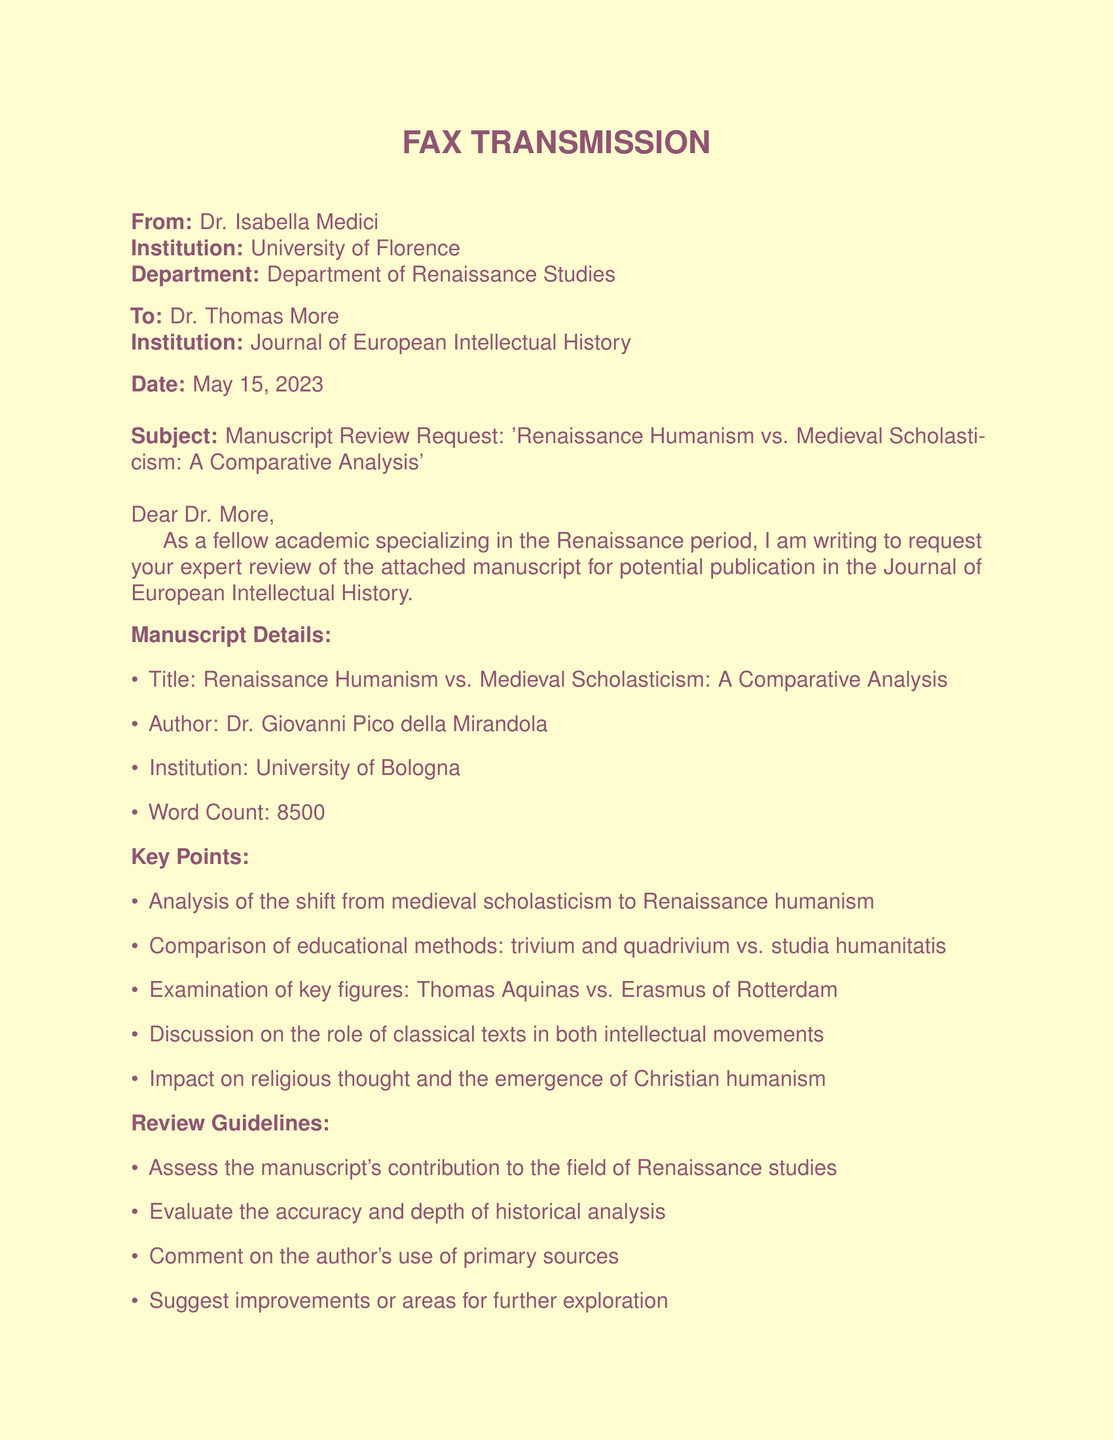What is the title of the manuscript? The title of the manuscript is indicated at the top of the key points section.
Answer: Renaissance Humanism vs. Medieval Scholasticism: A Comparative Analysis Who is the author of the manuscript? The author's name is specified in the manuscript details section.
Answer: Dr. Giovanni Pico della Mirandola What is the word count of the manuscript? The word count is explicitly mentioned in the manuscript details section.
Answer: 8500 When is the review due? The review submission deadline is stated towards the end of the document.
Answer: June 12, 2023 What are the key educational methods compared? The key educational methods are listed under the key points section.
Answer: trivium and quadrivium vs. studia humanitatis Who is suggested as a key figure in comparison with Erasmus of Rotterdam? The comparison includes prominent figures listed in the key points section.
Answer: Thomas Aquinas What does the document request from Dr. More? The document specifies a request directed toward Dr. More in the introductory paragraph.
Answer: Expert review of the manuscript What is the primary focus of the manuscript? The initial part of the document presents the main subject of analysis.
Answer: Shift from medieval scholasticism to Renaissance humanism Who is the sender of the fax? The sender's information is outlined at the beginning of the document.
Answer: Dr. Isabella Medici 